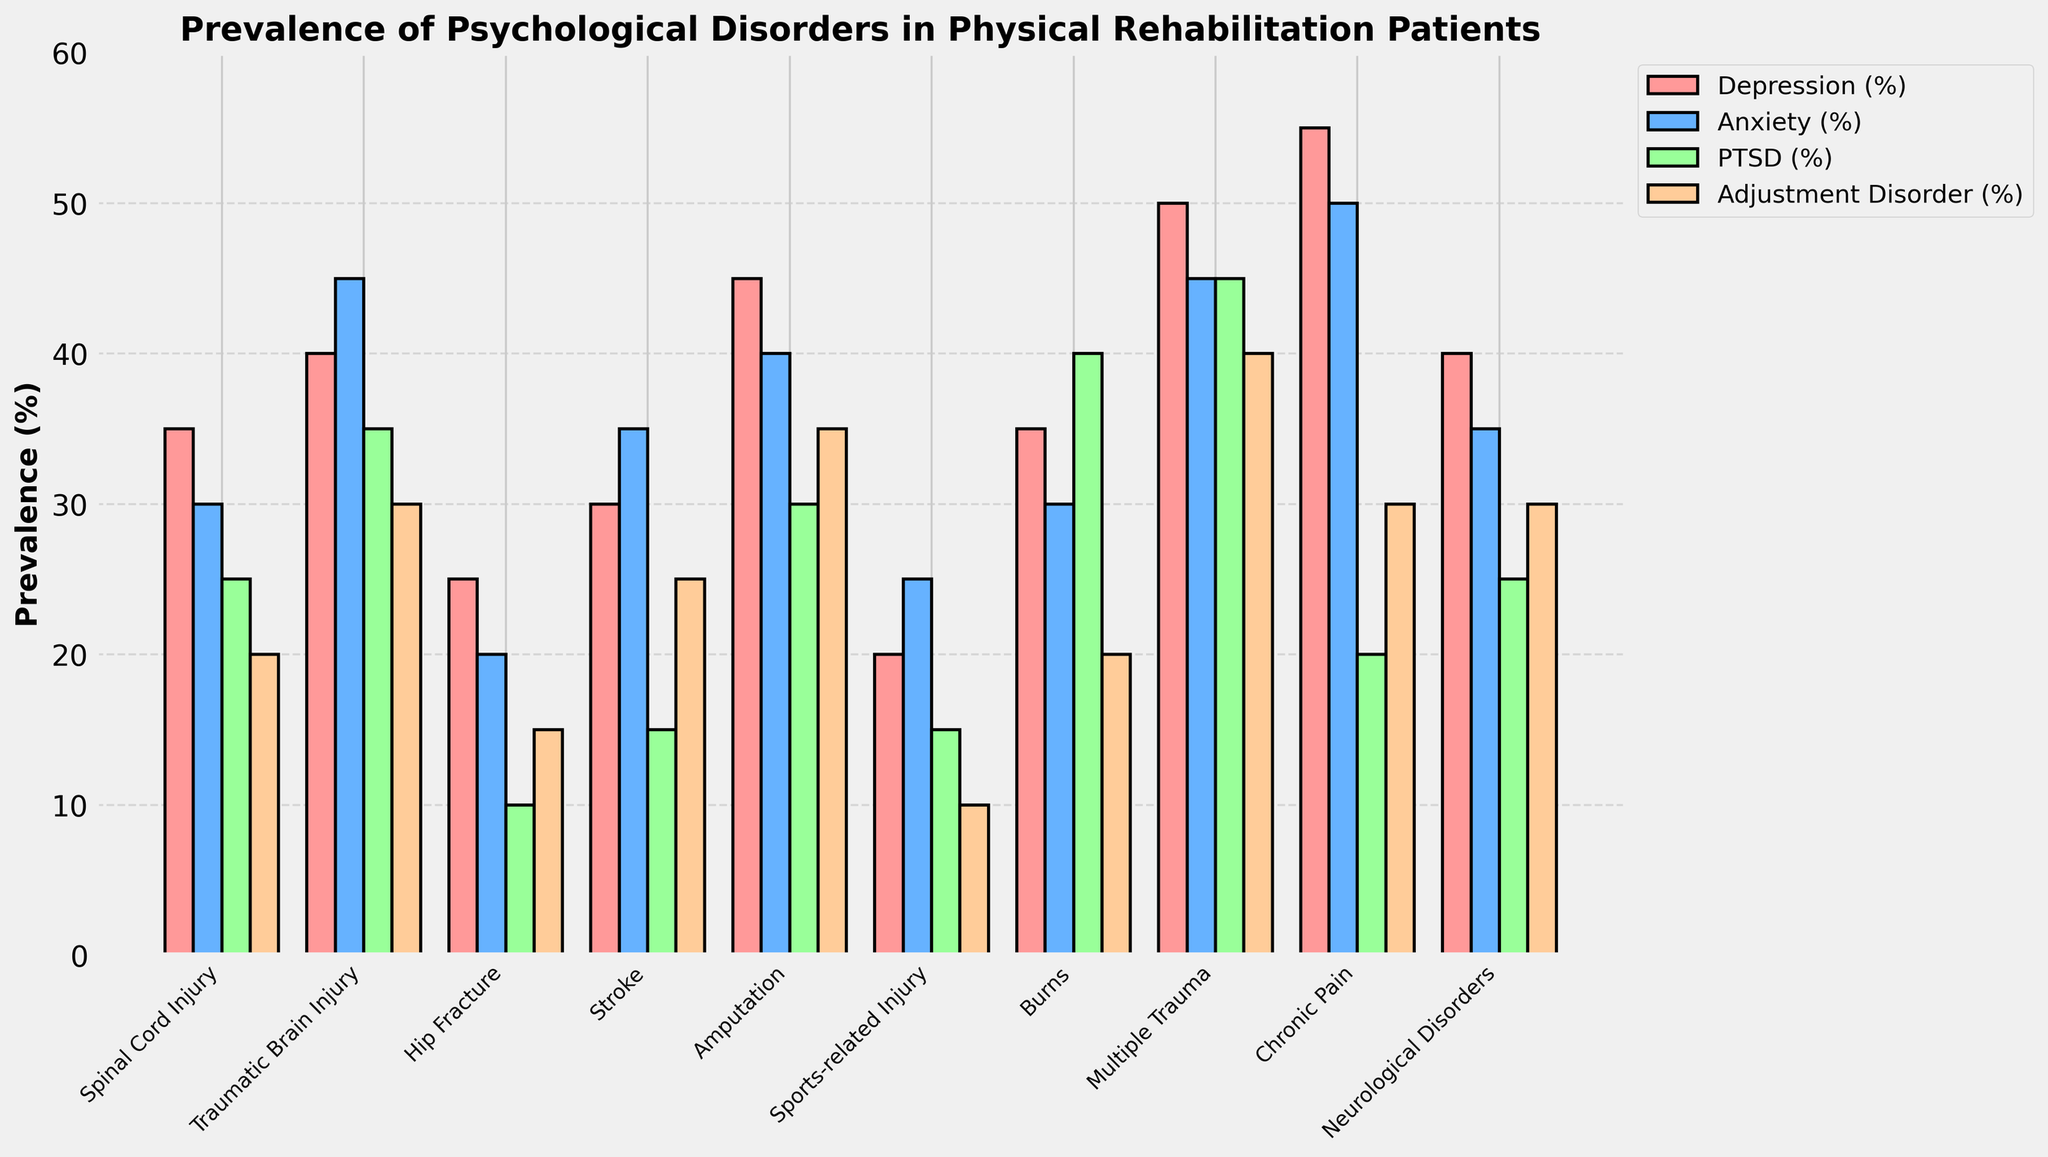What injury type has the highest prevalence of PTSD? By looking at the bar heights, "Burns" has the highest bar for PTSD, meaning the highest prevalence.
Answer: Burns Which psychological disorder has the highest prevalence among patients with chronic pain? By observing the heights of bars associated with chronic pain, the "Depression (%)" bar is the highest.
Answer: Depression What is the average prevalence of anxiety across all injury types? Sum the anxiety percentages (30 + 45 + 20 + 35 + 40 + 25 + 30 + 45 + 50 + 35) and divide by the number of injury types (10) to find the average: (30 + 45 + 20 + 35 + 40 + 25 + 30 + 45 + 50 + 35) / 10 = 35
Answer: 35% Which two injury types have the closest prevalence of depression? By comparing the heights of the "Depression (%)" bars, "Traumatic Brain Injury" and "Neurological Disorders" are very close at 40%.
Answer: Traumatic Brain Injury and Neurological Disorders How many injury types have a PTSD prevalence of 30% or more? Count the bars for PTSD that are at or above the 30% mark. These are for "Traumatic Brain Injury", "Amputation", "Burns", "Multiple Trauma".
Answer: 4 Which psychological disorder is the least prevalent in patients with sports-related injuries? By observing the heights of the bars related to sports-related injuries, "Adjustment Disorder (%)" is the shortest.
Answer: Adjustment Disorder How much higher is the prevalence of adjustment disorder in patients with multiple trauma as compared to those with hip fractures? Subtract the prevalence of adjustment disorder in hip fractures (15%) from that in multiple trauma (40%): 40% - 15% = 25%
Answer: 25% What is the most common psychological disorder among patients with neurological disorders? The tallest bar for neurological disorders is "Depression (%)".
Answer: Depression Which injury type shows the highest overall prevalence of psychological disorders when adding all four disorder percentages together? Sum up all disorder percentages for each injury type and find the highest sum. Multiple Trauma: 50+45+45+40 = 180%, which is the highest.
Answer: Multiple Trauma 